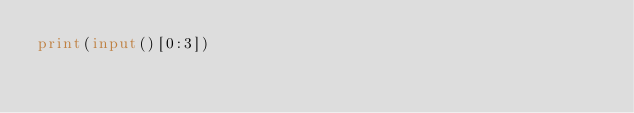<code> <loc_0><loc_0><loc_500><loc_500><_Python_>print(input()[0:3])</code> 